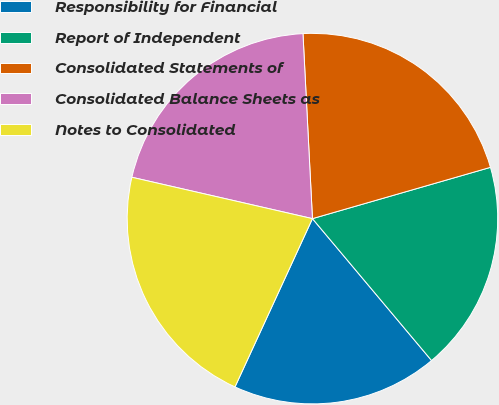Convert chart to OTSL. <chart><loc_0><loc_0><loc_500><loc_500><pie_chart><fcel>Responsibility for Financial<fcel>Report of Independent<fcel>Consolidated Statements of<fcel>Consolidated Balance Sheets as<fcel>Notes to Consolidated<nl><fcel>17.98%<fcel>18.35%<fcel>21.35%<fcel>20.6%<fcel>21.72%<nl></chart> 